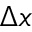<formula> <loc_0><loc_0><loc_500><loc_500>\Delta x</formula> 